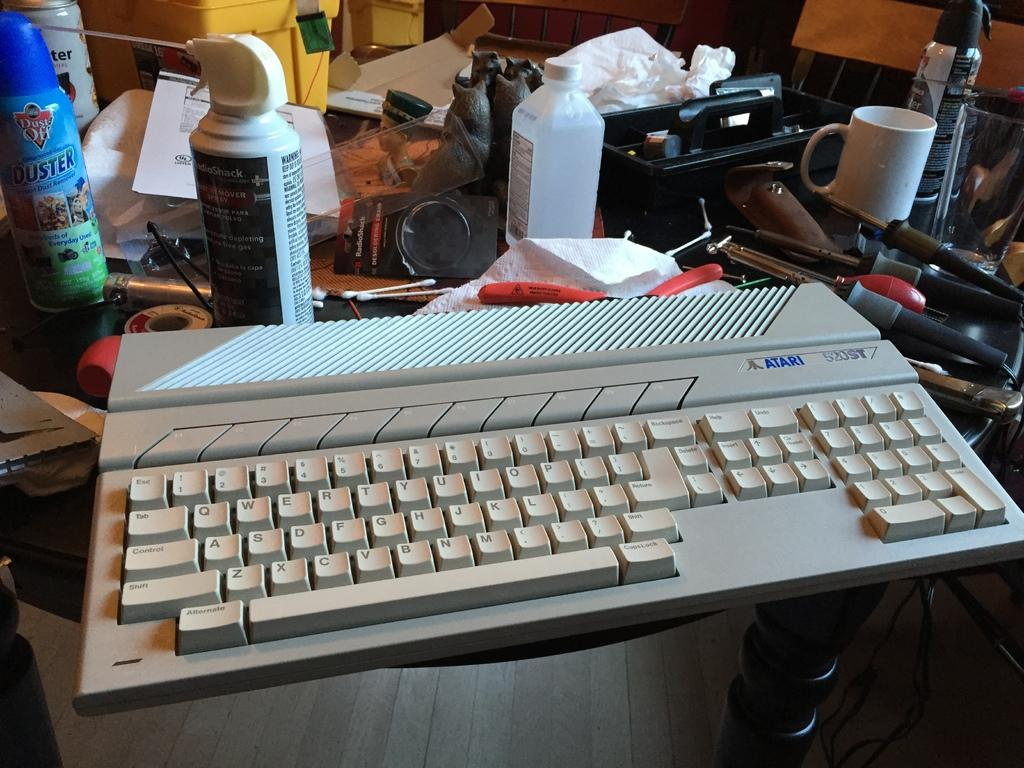<image>
Summarize the visual content of the image. a computer keyboard with the word Atari at the top 